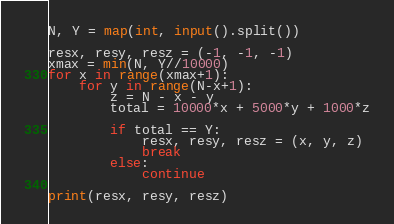<code> <loc_0><loc_0><loc_500><loc_500><_Python_>N, Y = map(int, input().split())

resx, resy, resz = (-1, -1, -1)
xmax = min(N, Y//10000)
for x in range(xmax+1):
    for y in range(N-x+1):
        z = N - x - y
        total = 10000*x + 5000*y + 1000*z

        if total == Y:
            resx, resy, resz = (x, y, z)
            break
        else:
            continue

print(resx, resy, resz)</code> 